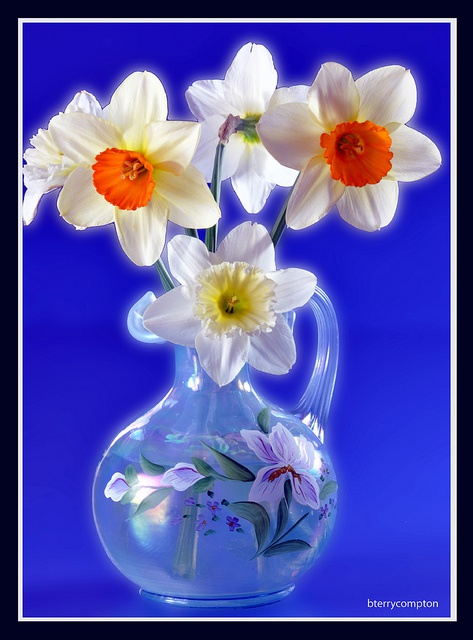Describe the objects in this image and their specific colors. I can see a vase in black, blue, gray, and darkgray tones in this image. 